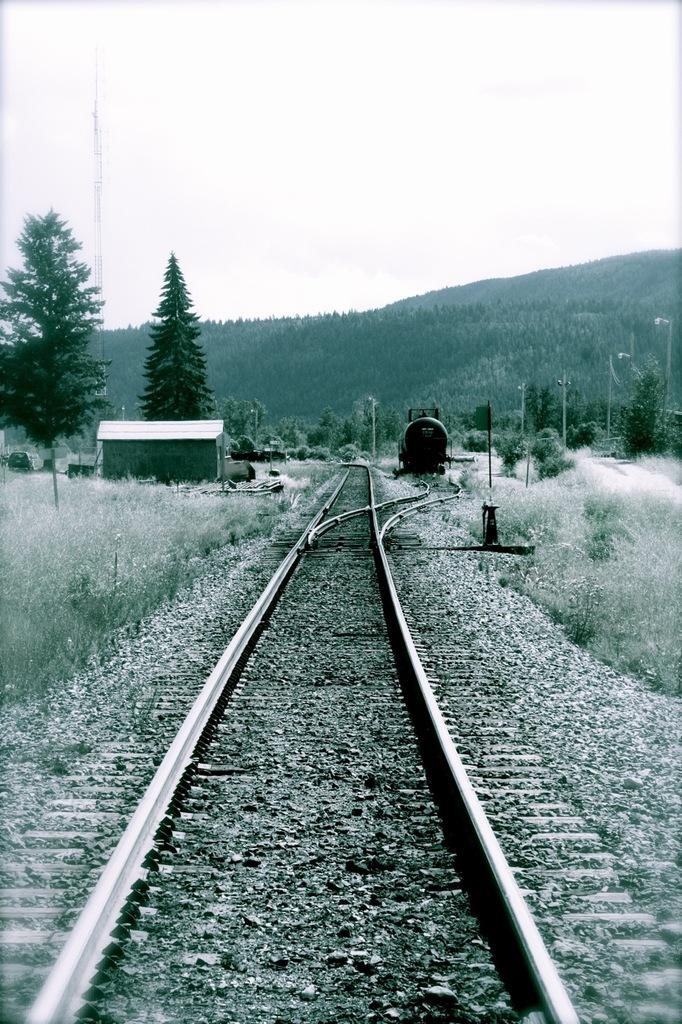What is the main feature of the image? There is a long railway track in the image. What can be seen on either side of the railway track? Bushes and trees are present on either side of the railway track. What is visible in the distance? There are mountains visible in the distance. What part of the natural environment is visible in the image? The sky is visible in the image. How many kittens can be seen playing on the railway track in the image? There are no kittens present in the image; it features a railway track, bushes, trees, mountains, and the sky. 